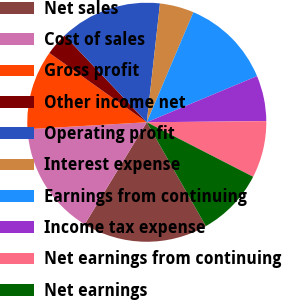Convert chart. <chart><loc_0><loc_0><loc_500><loc_500><pie_chart><fcel>Net sales<fcel>Cost of sales<fcel>Gross profit<fcel>Other income net<fcel>Operating profit<fcel>Interest expense<fcel>Earnings from continuing<fcel>Income tax expense<fcel>Net earnings from continuing<fcel>Net earnings<nl><fcel>16.92%<fcel>15.38%<fcel>10.77%<fcel>3.08%<fcel>13.84%<fcel>4.62%<fcel>12.31%<fcel>6.16%<fcel>7.69%<fcel>9.23%<nl></chart> 